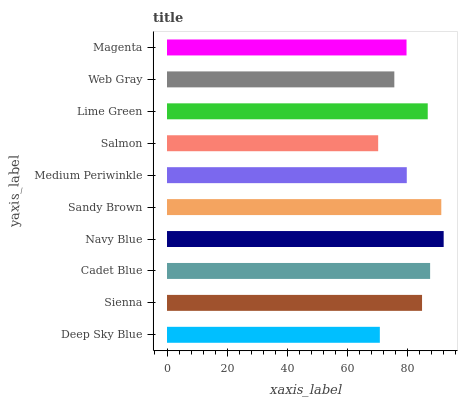Is Salmon the minimum?
Answer yes or no. Yes. Is Navy Blue the maximum?
Answer yes or no. Yes. Is Sienna the minimum?
Answer yes or no. No. Is Sienna the maximum?
Answer yes or no. No. Is Sienna greater than Deep Sky Blue?
Answer yes or no. Yes. Is Deep Sky Blue less than Sienna?
Answer yes or no. Yes. Is Deep Sky Blue greater than Sienna?
Answer yes or no. No. Is Sienna less than Deep Sky Blue?
Answer yes or no. No. Is Sienna the high median?
Answer yes or no. Yes. Is Medium Periwinkle the low median?
Answer yes or no. Yes. Is Web Gray the high median?
Answer yes or no. No. Is Cadet Blue the low median?
Answer yes or no. No. 